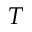<formula> <loc_0><loc_0><loc_500><loc_500>T</formula> 